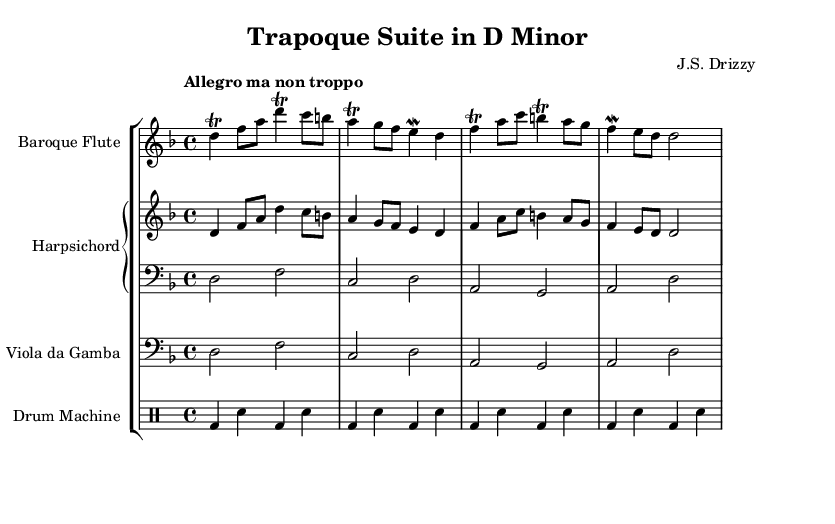What is the key signature of this music? The key signature is D minor, which has one flat (B flat).
Answer: D minor What is the time signature of the piece? The time signature is 4/4, indicating four beats in each measure.
Answer: 4/4 What is the tempo marking for this piece? The tempo marking is "Allegro ma non troppo," suggesting a lively speed but not excessively fast.
Answer: Allegro ma non troppo How many measures are present in the harpsichord part? There are four measures in the harpsichord part, as counted from the musical notation.
Answer: Four Which instrument is playing the trill in the first measure? The flute is performing the trill in the first measure, as shown in the flute staff.
Answer: Flute What rhythmic pattern is used for the drum machine? The drum machine uses a pattern of bass drums (bd) and snares (sn) that alternate every beat.
Answer: Bass drum and snare What type of musical form is represented in this Baroque dance suite? The piece represents a dance suite, commonly consisting of a series of dance movements.
Answer: Dance suite 